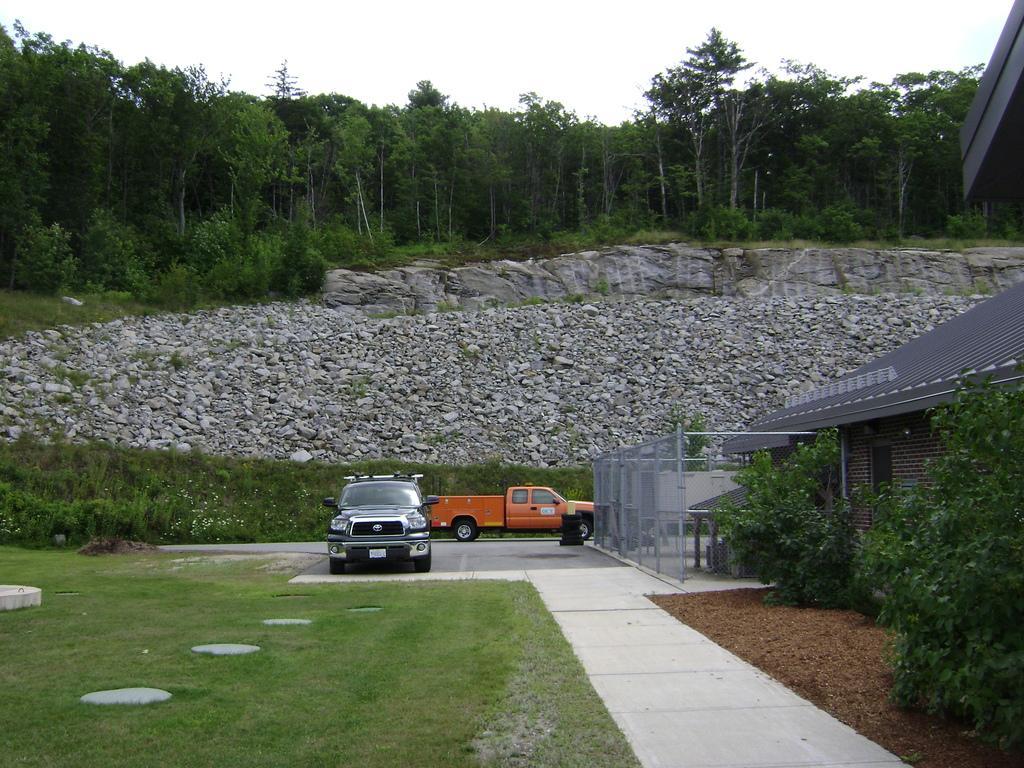Please provide a concise description of this image. In this picture we can see couple of cars, beside to the cars we can find fence and a house, in the background we can see few rocks and trees. 